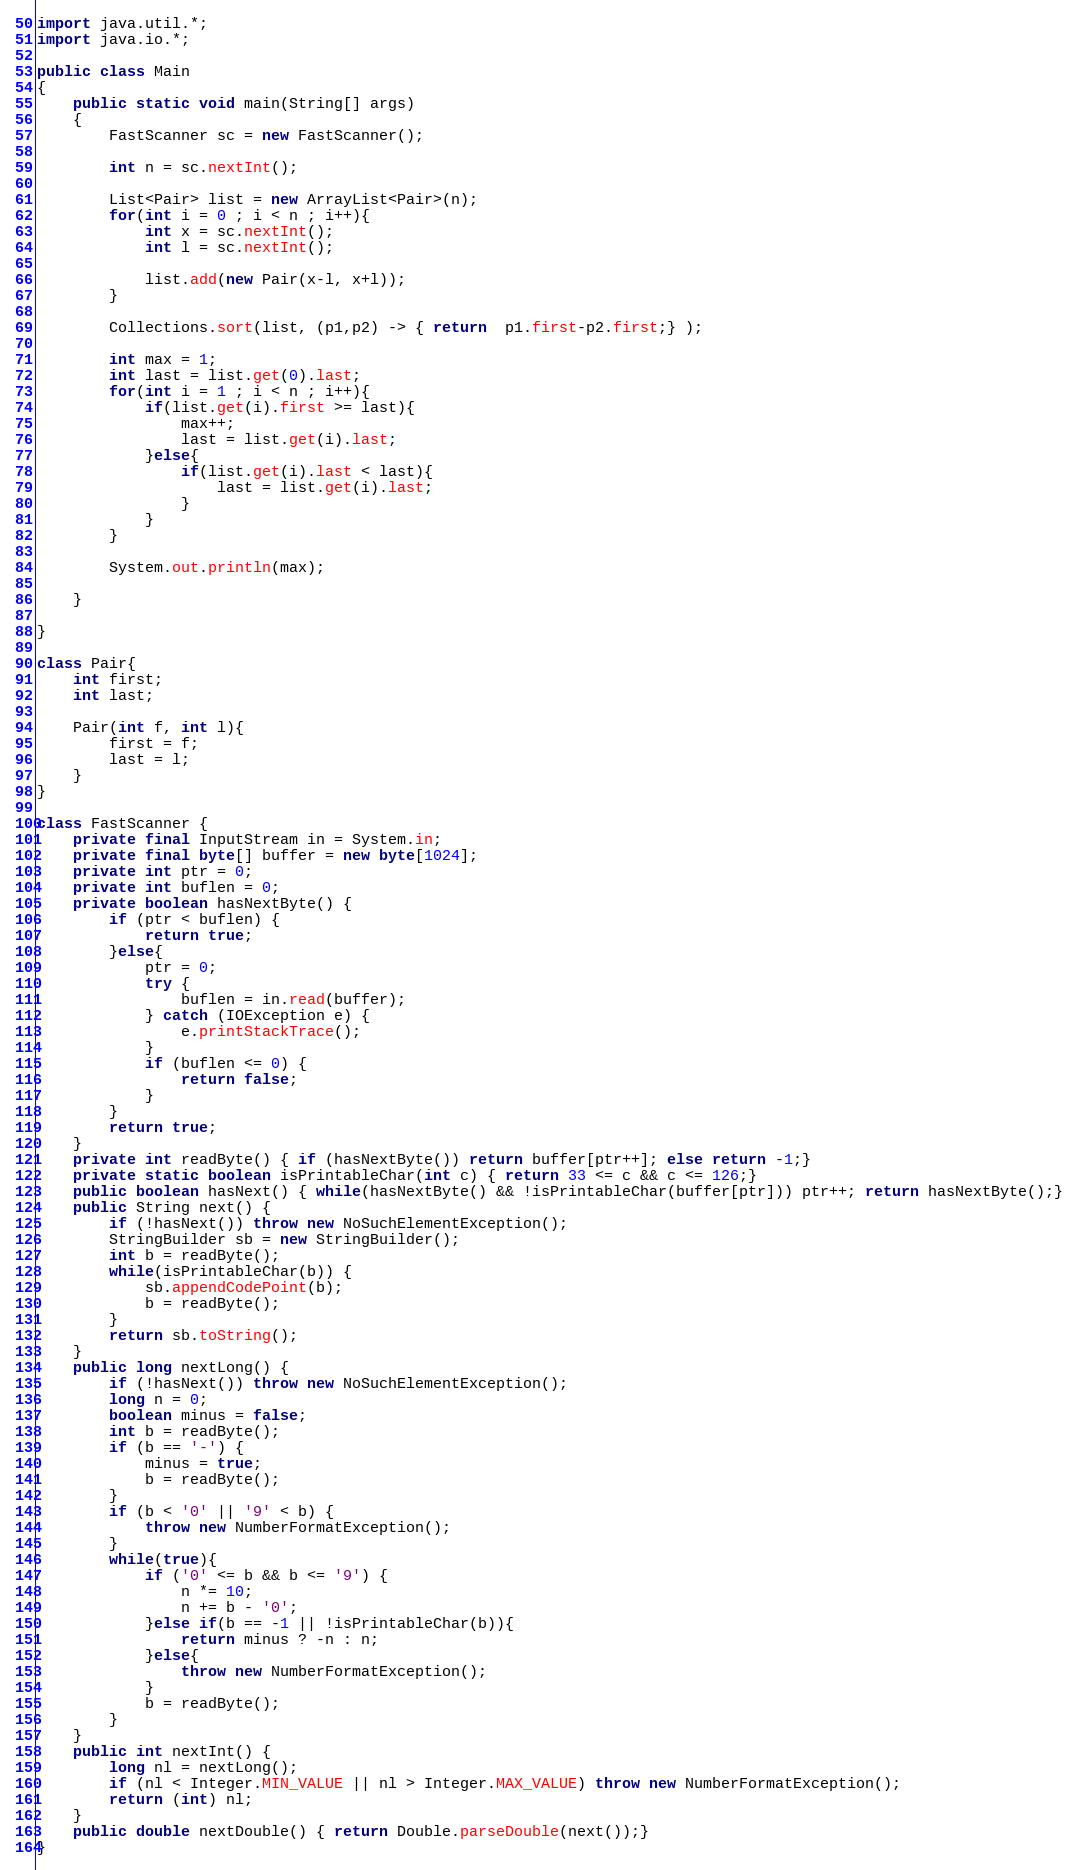<code> <loc_0><loc_0><loc_500><loc_500><_Java_>import java.util.*;
import java.io.*;

public class Main
{
	public static void main(String[] args)
	{
		FastScanner sc = new FastScanner();

		int n = sc.nextInt();

		List<Pair> list = new ArrayList<Pair>(n);
		for(int i = 0 ; i < n ; i++){
			int x = sc.nextInt();
			int l = sc.nextInt();

			list.add(new Pair(x-l, x+l));
		}

		Collections.sort(list, (p1,p2) -> { return  p1.first-p2.first;} );

		int max = 1;
		int last = list.get(0).last;
		for(int i = 1 ; i < n ; i++){
			if(list.get(i).first >= last){
				max++;
				last = list.get(i).last;
			}else{
				if(list.get(i).last < last){
					last = list.get(i).last;
				}
			}
		}

		System.out.println(max);

	}

}

class Pair{
	int first;
	int last;

	Pair(int f, int l){
		first = f;
		last = l;
	}
}

class FastScanner {
    private final InputStream in = System.in;
    private final byte[] buffer = new byte[1024];
    private int ptr = 0;
    private int buflen = 0;
    private boolean hasNextByte() {
        if (ptr < buflen) {
            return true;
        }else{
            ptr = 0;
            try {
                buflen = in.read(buffer);
            } catch (IOException e) {
                e.printStackTrace();
            }
            if (buflen <= 0) {
                return false;
            }
        }
        return true;
    }
    private int readByte() { if (hasNextByte()) return buffer[ptr++]; else return -1;}
    private static boolean isPrintableChar(int c) { return 33 <= c && c <= 126;}
    public boolean hasNext() { while(hasNextByte() && !isPrintableChar(buffer[ptr])) ptr++; return hasNextByte();}
    public String next() {
        if (!hasNext()) throw new NoSuchElementException();
        StringBuilder sb = new StringBuilder();
        int b = readByte();
        while(isPrintableChar(b)) {
            sb.appendCodePoint(b);
            b = readByte();
        }
        return sb.toString();
    }
    public long nextLong() {
        if (!hasNext()) throw new NoSuchElementException();
        long n = 0;
        boolean minus = false;
        int b = readByte();
        if (b == '-') {
            minus = true;
            b = readByte();
        }
        if (b < '0' || '9' < b) {
            throw new NumberFormatException();
        }
        while(true){
            if ('0' <= b && b <= '9') {
                n *= 10;
                n += b - '0';
            }else if(b == -1 || !isPrintableChar(b)){
                return minus ? -n : n;
            }else{
                throw new NumberFormatException();
            }
            b = readByte();
        }
    }
    public int nextInt() {
        long nl = nextLong();
        if (nl < Integer.MIN_VALUE || nl > Integer.MAX_VALUE) throw new NumberFormatException();
        return (int) nl;
    }
    public double nextDouble() { return Double.parseDouble(next());}
}</code> 